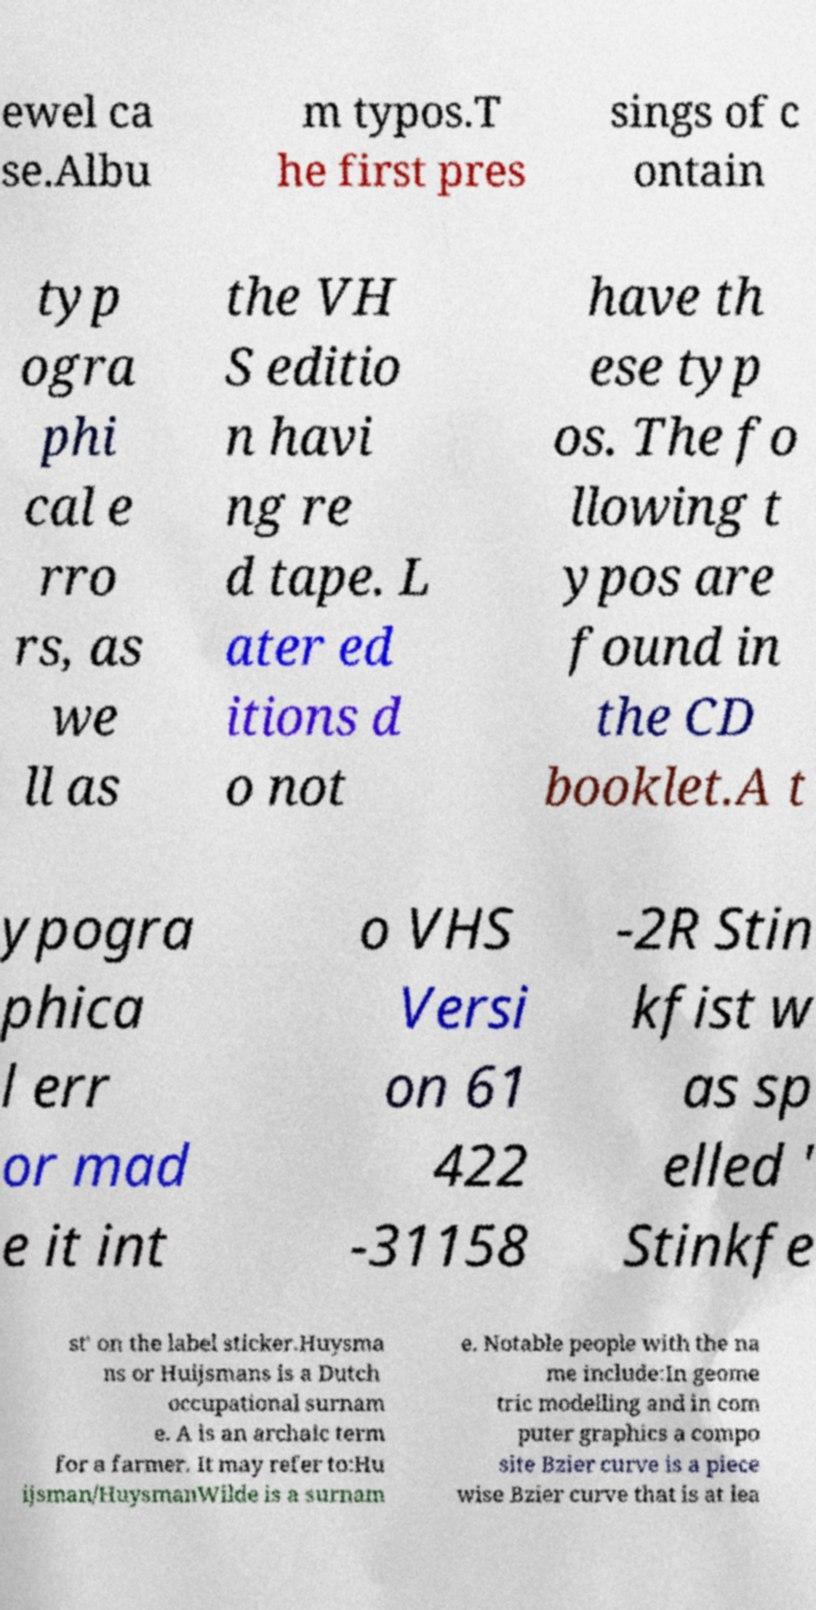Can you accurately transcribe the text from the provided image for me? ewel ca se.Albu m typos.T he first pres sings of c ontain typ ogra phi cal e rro rs, as we ll as the VH S editio n havi ng re d tape. L ater ed itions d o not have th ese typ os. The fo llowing t ypos are found in the CD booklet.A t ypogra phica l err or mad e it int o VHS Versi on 61 422 -31158 -2R Stin kfist w as sp elled ' Stinkfe st' on the label sticker.Huysma ns or Huijsmans is a Dutch occupational surnam e. A is an archaic term for a farmer. It may refer to:Hu ijsman/HuysmanWilde is a surnam e. Notable people with the na me include:In geome tric modelling and in com puter graphics a compo site Bzier curve is a piece wise Bzier curve that is at lea 